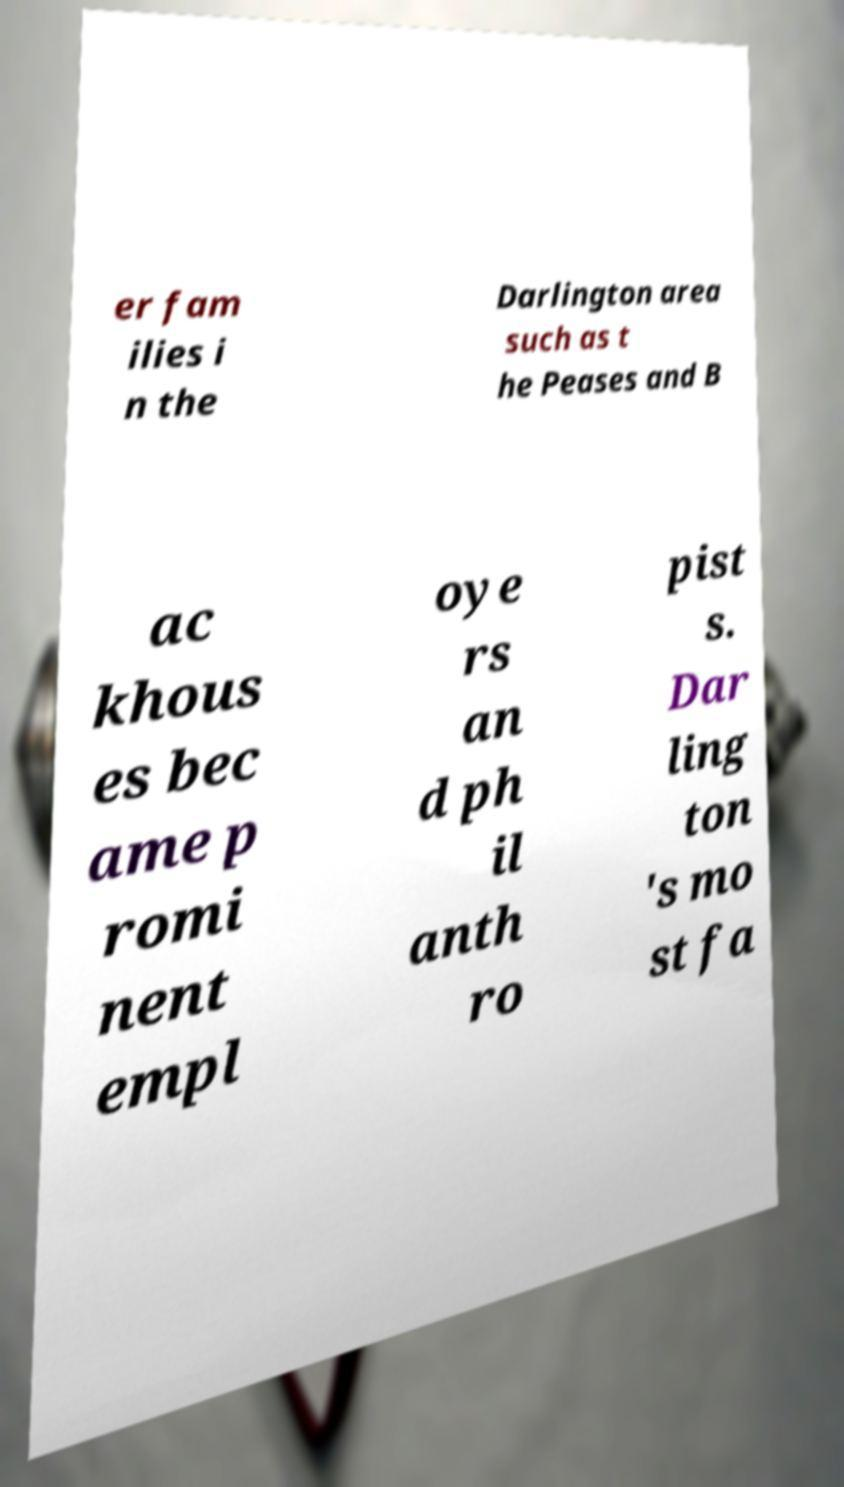I need the written content from this picture converted into text. Can you do that? er fam ilies i n the Darlington area such as t he Peases and B ac khous es bec ame p romi nent empl oye rs an d ph il anth ro pist s. Dar ling ton 's mo st fa 